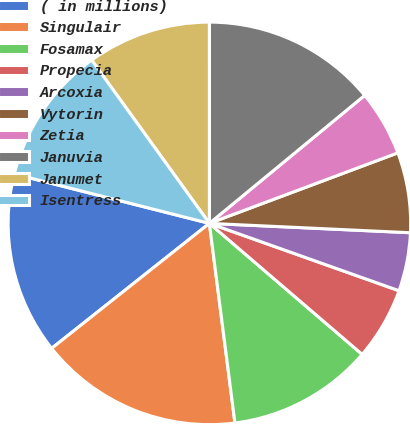<chart> <loc_0><loc_0><loc_500><loc_500><pie_chart><fcel>( in millions)<fcel>Singulair<fcel>Fosamax<fcel>Propecia<fcel>Arcoxia<fcel>Vytorin<fcel>Zetia<fcel>Januvia<fcel>Janumet<fcel>Isentress<nl><fcel>14.61%<fcel>16.36%<fcel>11.69%<fcel>5.85%<fcel>4.69%<fcel>6.44%<fcel>5.27%<fcel>14.03%<fcel>9.94%<fcel>11.11%<nl></chart> 